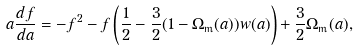<formula> <loc_0><loc_0><loc_500><loc_500>a \frac { d f } { d a } = - f ^ { 2 } - f \left ( \frac { 1 } { 2 } - \frac { 3 } { 2 } ( 1 - \Omega _ { \text {m} } ( a ) ) w ( a ) \right ) + \frac { 3 } { 2 } \Omega _ { \text {m} } ( a ) ,</formula> 